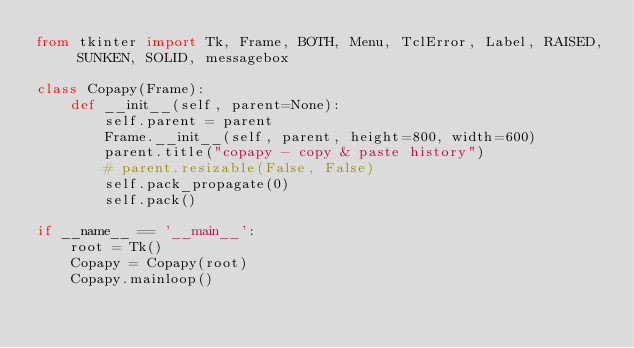Convert code to text. <code><loc_0><loc_0><loc_500><loc_500><_Python_>from tkinter import Tk, Frame, BOTH, Menu, TclError, Label, RAISED, SUNKEN, SOLID, messagebox

class Copapy(Frame):
    def __init__(self, parent=None):
        self.parent = parent
        Frame.__init__(self, parent, height=800, width=600)
        parent.title("copapy - copy & paste history")
        # parent.resizable(False, False)
        self.pack_propagate(0)
        self.pack()

if __name__ == '__main__':
    root = Tk()
    Copapy = Copapy(root)
    Copapy.mainloop()
</code> 